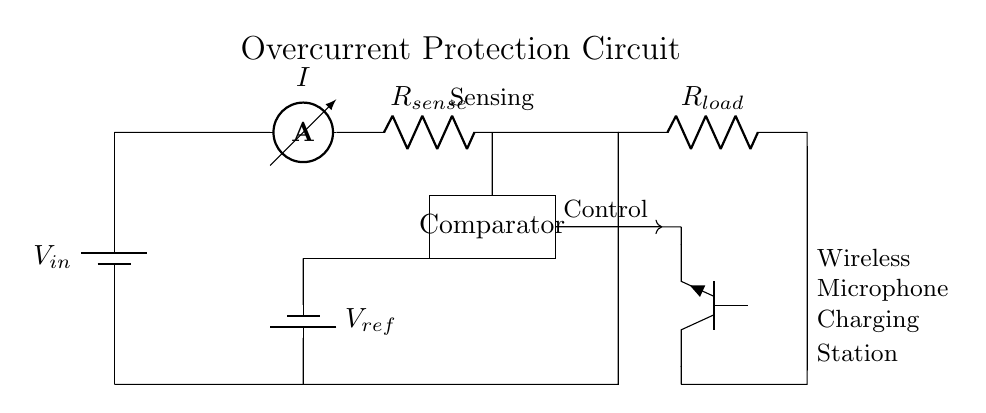What is the type of battery used in this circuit? The diagram indicates a standard battery symbol, labeled as V in, which refers to the input voltage source, typically a primary battery or rechargeable battery used to power the circuit.
Answer: Battery What is the purpose of the R sense resistor? The R sense resistor is used to monitor the current flowing through the circuit. By measuring the voltage drop across R sense, we can determine the amount of current (I) flowing, which is essential for overcurrent protection.
Answer: Current monitoring What component provides a reference voltage? The reference voltage is provided by the second battery labeled as V ref. This component establishes a threshold against which the sensed voltage is compared to determine if the circuit is operating within safe limits.
Answer: V ref What component acts as the control signal transmitter? The control signal is transmitted via an arrow indicating a connection from the comparator to the base of the transistor (T npn), influencing its operation depending on the comparison outcome of the voltages.
Answer: Transistor What happens when the current exceeds the set threshold? When the current exceeds the threshold set by R sense and V ref, the comparator output activates the transistor, cutting off the load (R load) to prevent damage, effectively providing overcurrent protection.
Answer: Load cutoff How many main components are involved in this overcurrent protection circuit? The main components in the circuit include a voltage source (battery), R sense (resistor), comparator, V ref (battery), transistor, and R load. By counting these, we find that there are a total of six primary components.
Answer: Six components What is the function of the comparator in this circuit? The comparator functions to dynamically compare the sensed voltage (across R sense) with the reference voltage (V ref). If the sensed voltage exceeds the reference voltage, it activates the transistor to disconnect the load, ensuring the circuit remains safe.
Answer: Voltage comparison 